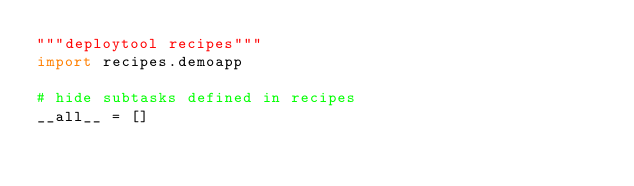Convert code to text. <code><loc_0><loc_0><loc_500><loc_500><_Python_>"""deploytool recipes"""
import recipes.demoapp

# hide subtasks defined in recipes
__all__ = []
</code> 